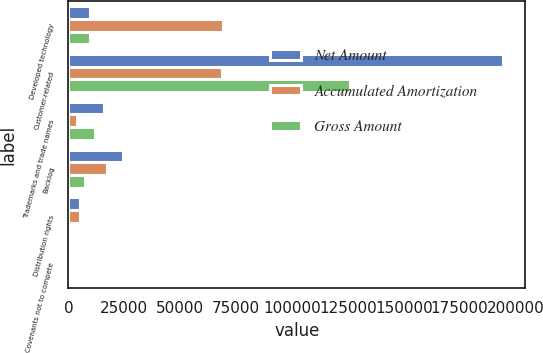Convert chart. <chart><loc_0><loc_0><loc_500><loc_500><stacked_bar_chart><ecel><fcel>Developed technology<fcel>Customer-related<fcel>Trademarks and trade names<fcel>Backlog<fcel>Distribution rights<fcel>Covenants not to compete<nl><fcel>Net Amount<fcel>9544.5<fcel>194500<fcel>15730<fcel>24610<fcel>5236<fcel>400<nl><fcel>Accumulated Amortization<fcel>69107<fcel>68522<fcel>3941<fcel>17310<fcel>5101<fcel>333<nl><fcel>Gross Amount<fcel>9544.5<fcel>125978<fcel>11789<fcel>7300<fcel>135<fcel>67<nl></chart> 